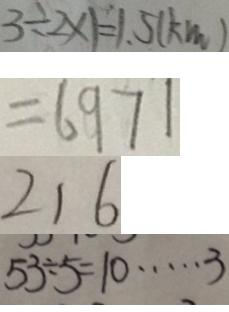Convert formula to latex. <formula><loc_0><loc_0><loc_500><loc_500>3 \div 2 \times 1 = 1 . 5 ( k m ) 
 = 6 9 7 1 
 2 1 6 
 5 3 \div 5 = 1 0 \cdots 3</formula> 